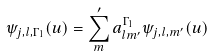Convert formula to latex. <formula><loc_0><loc_0><loc_500><loc_500>\psi _ { j , l , \Gamma _ { 1 } } ( u ) = \sum _ { m } ^ { \prime } a ^ { \Gamma _ { 1 } } _ { l m ^ { \prime } } \psi _ { j , l , m ^ { \prime } } ( u )</formula> 